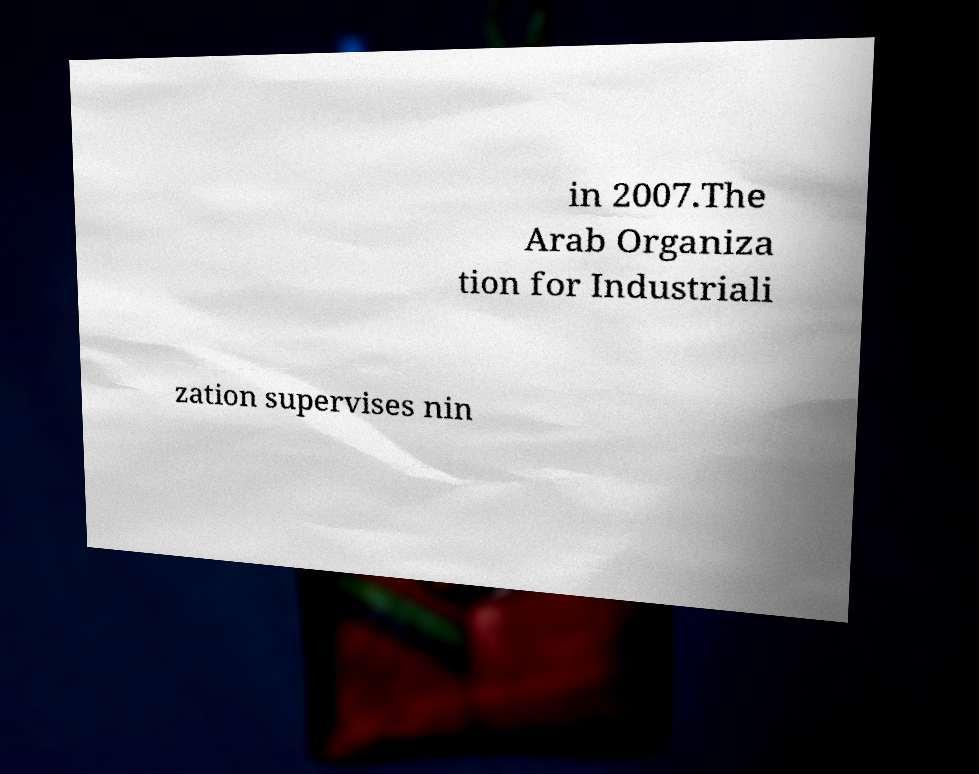Could you extract and type out the text from this image? in 2007.The Arab Organiza tion for Industriali zation supervises nin 